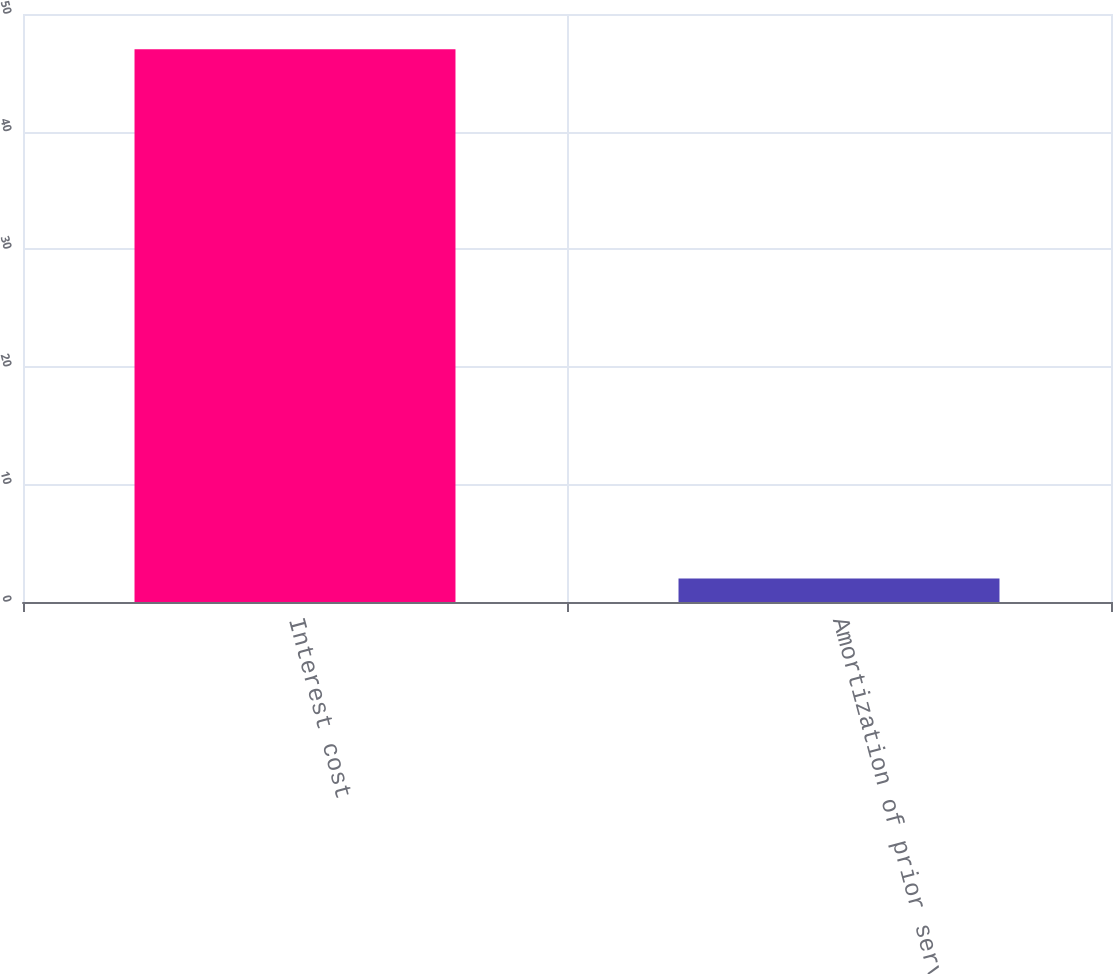<chart> <loc_0><loc_0><loc_500><loc_500><bar_chart><fcel>Interest cost<fcel>Amortization of prior service<nl><fcel>47<fcel>2<nl></chart> 